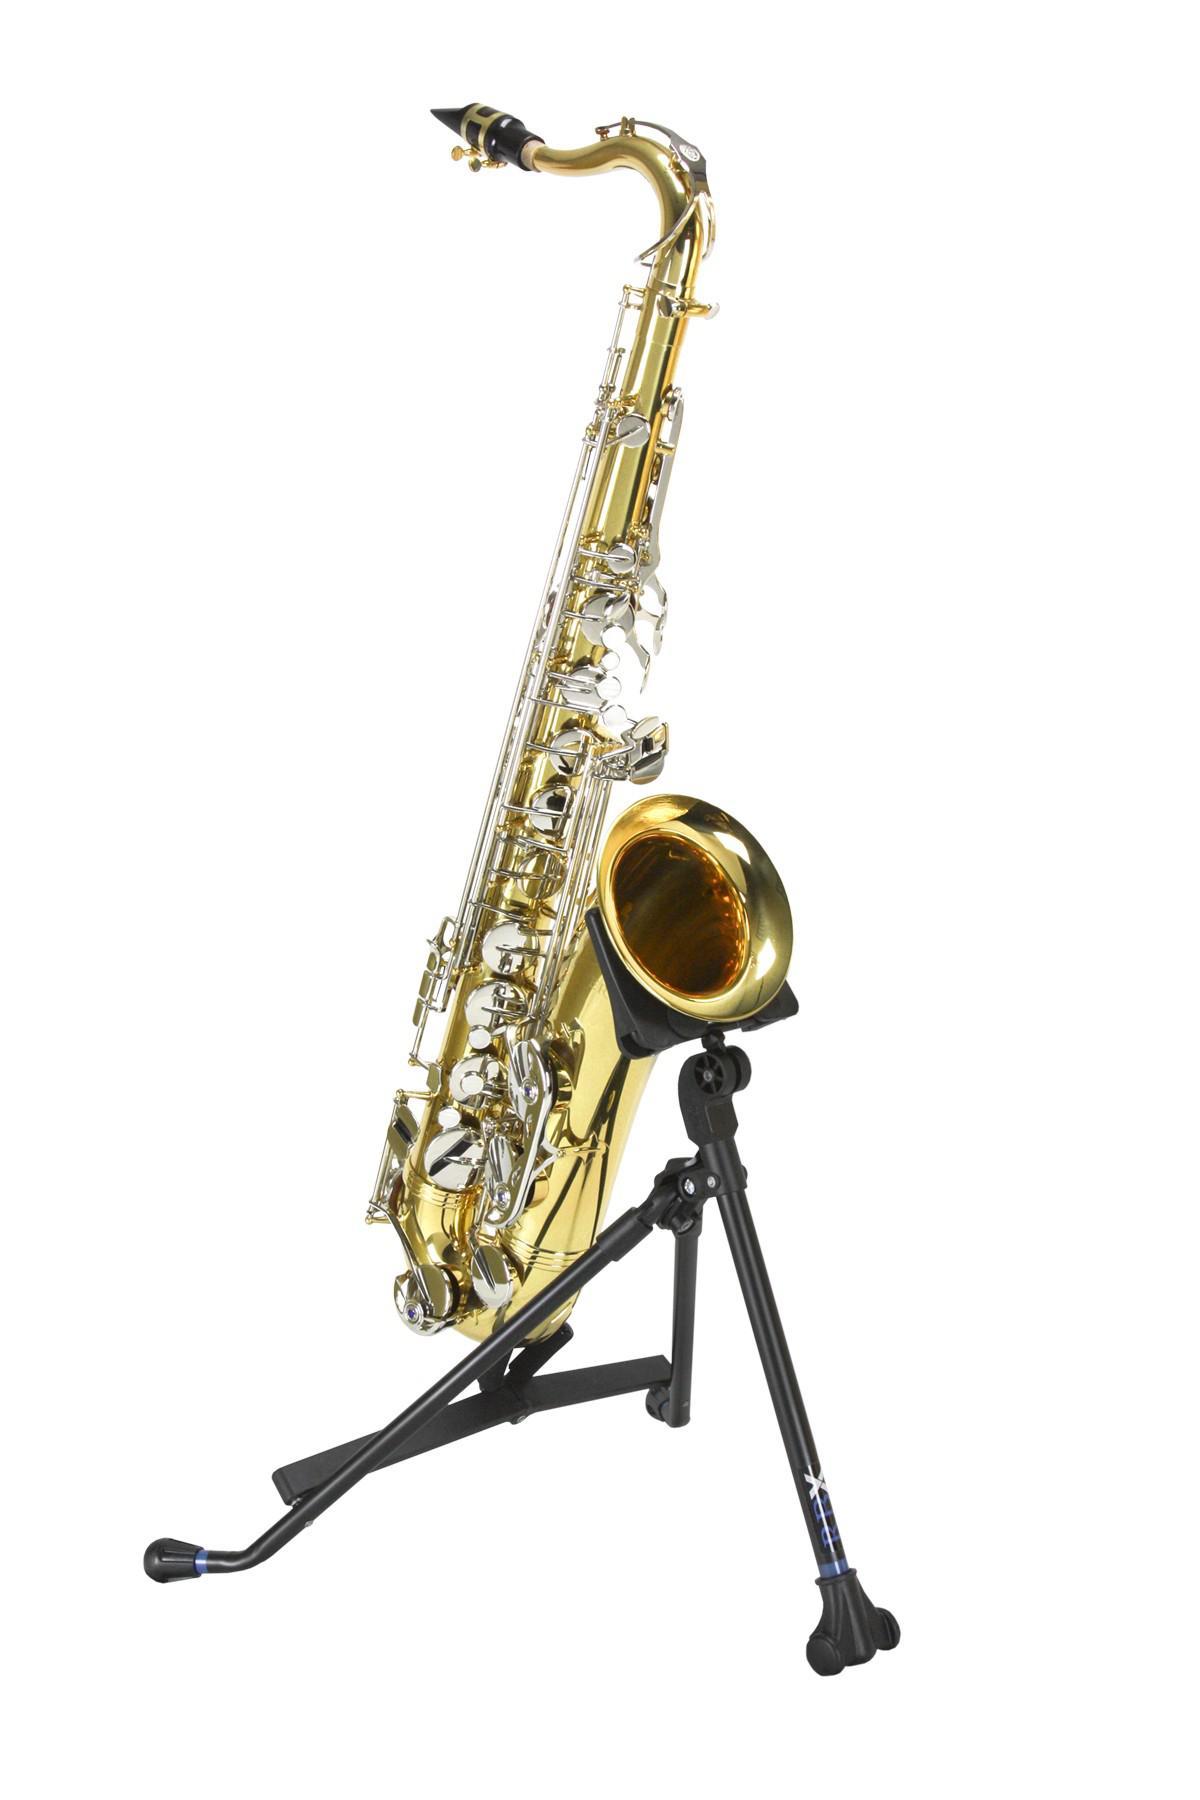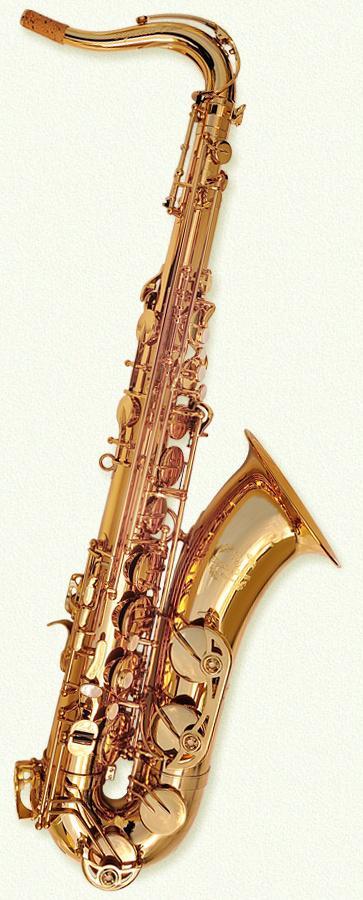The first image is the image on the left, the second image is the image on the right. For the images shown, is this caption "The full length of two saxophones are shown, each of them a different color, but both with a mouthpiece of the same shape." true? Answer yes or no. Yes. The first image is the image on the left, the second image is the image on the right. Given the left and right images, does the statement "A gold-colored right-facing saxophone is displayed fully upright on a black background." hold true? Answer yes or no. No. 